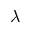<formula> <loc_0><loc_0><loc_500><loc_500>\lambda</formula> 